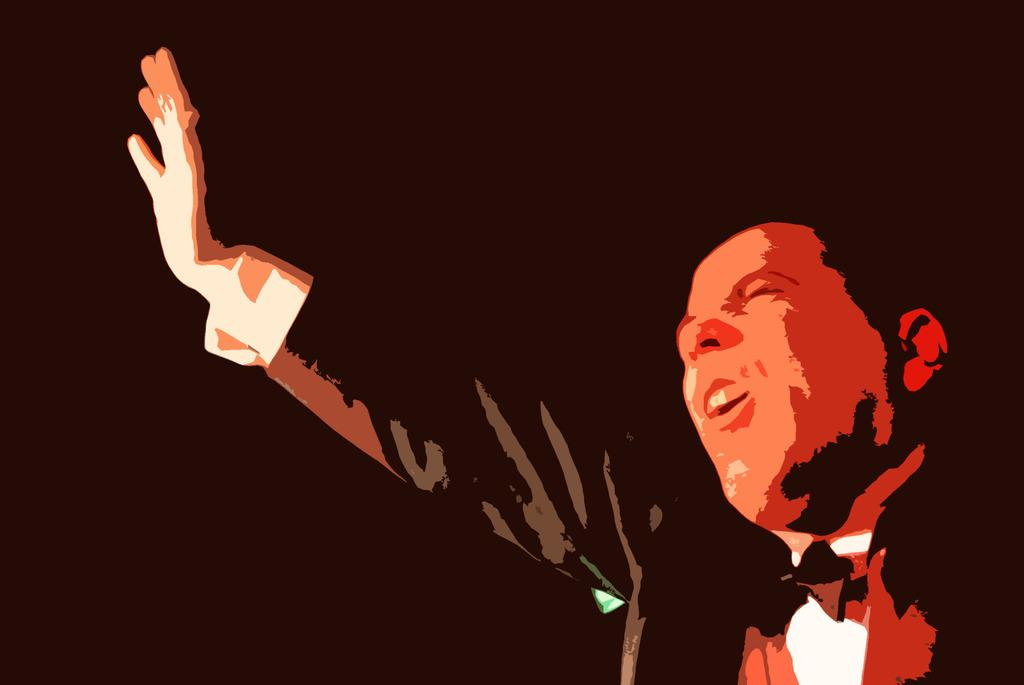Who is present in the image? There is a man in the image. What is the man wearing around his neck? The man is wearing a bow tie. What can be observed about the background of the image? The background of the image is dark. What type of chair is the parent sitting on in the image? There is no parent or chair present in the image; it only features a man wearing a bow tie. What kind of vessel is being used by the man in the image? There is no vessel present in the image; the man is not shown using any object. 